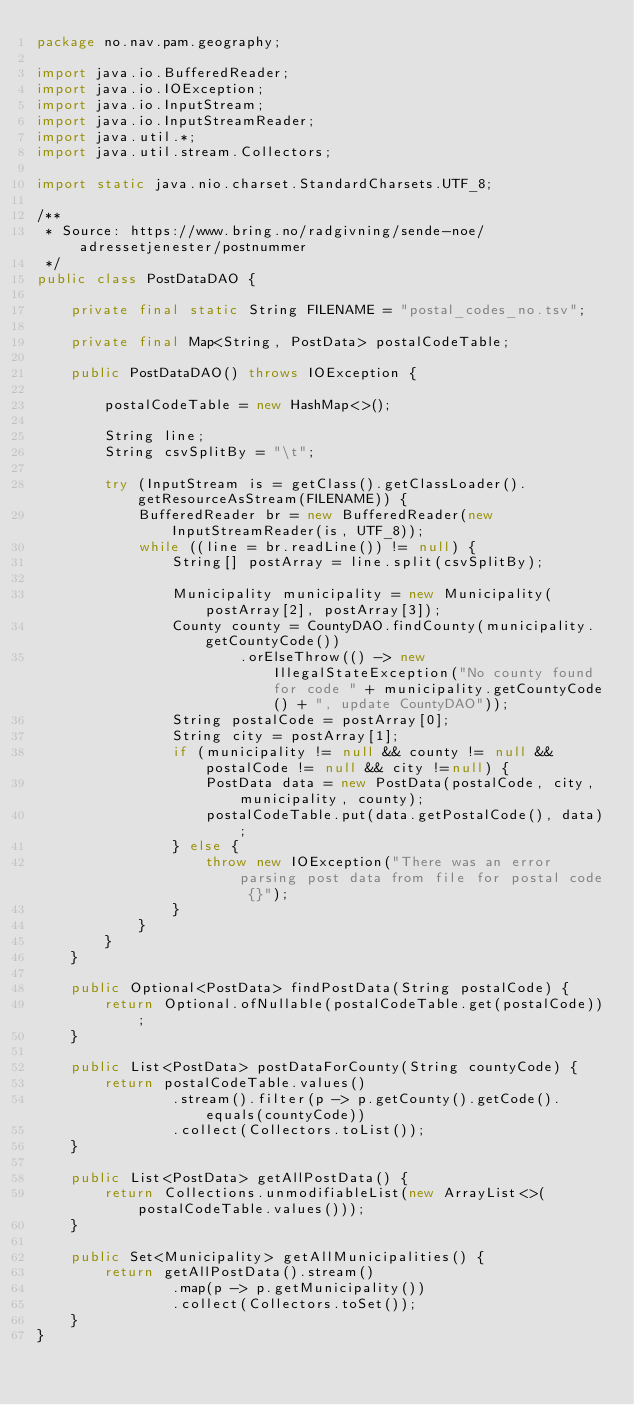Convert code to text. <code><loc_0><loc_0><loc_500><loc_500><_Java_>package no.nav.pam.geography;

import java.io.BufferedReader;
import java.io.IOException;
import java.io.InputStream;
import java.io.InputStreamReader;
import java.util.*;
import java.util.stream.Collectors;

import static java.nio.charset.StandardCharsets.UTF_8;

/**
 * Source: https://www.bring.no/radgivning/sende-noe/adressetjenester/postnummer
 */
public class PostDataDAO {

    private final static String FILENAME = "postal_codes_no.tsv";

    private final Map<String, PostData> postalCodeTable;

    public PostDataDAO() throws IOException {

        postalCodeTable = new HashMap<>();

        String line;
        String csvSplitBy = "\t";

        try (InputStream is = getClass().getClassLoader().getResourceAsStream(FILENAME)) {
            BufferedReader br = new BufferedReader(new InputStreamReader(is, UTF_8));
            while ((line = br.readLine()) != null) {
                String[] postArray = line.split(csvSplitBy);

                Municipality municipality = new Municipality(postArray[2], postArray[3]);
                County county = CountyDAO.findCounty(municipality.getCountyCode())
                        .orElseThrow(() -> new IllegalStateException("No county found for code " + municipality.getCountyCode() + ", update CountyDAO"));
                String postalCode = postArray[0];
                String city = postArray[1];
                if (municipality != null && county != null && postalCode != null && city !=null) {
                    PostData data = new PostData(postalCode, city, municipality, county);
                    postalCodeTable.put(data.getPostalCode(), data);
                } else {
                    throw new IOException("There was an error parsing post data from file for postal code {}");
                }
            }
        }
    }

    public Optional<PostData> findPostData(String postalCode) {
        return Optional.ofNullable(postalCodeTable.get(postalCode));
    }

    public List<PostData> postDataForCounty(String countyCode) {
        return postalCodeTable.values()
                .stream().filter(p -> p.getCounty().getCode().equals(countyCode))
                .collect(Collectors.toList());
    }

    public List<PostData> getAllPostData() {
        return Collections.unmodifiableList(new ArrayList<>(postalCodeTable.values()));
    }

    public Set<Municipality> getAllMunicipalities() {
        return getAllPostData().stream()
                .map(p -> p.getMunicipality())
                .collect(Collectors.toSet());
    }
}
</code> 